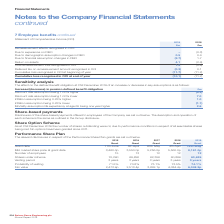According to Spirax Sarco Engineering Plc's financial document, What are the relevant disclosures in the table pertaining to? in respect of the Performance Share Plan grants. The document states: "Performance Share Plan The relevant disclosures in respect of the Performance Share Plan grants are set out below...." Also, What was the number of employees under the 2015 Grant? According to the financial document, 15. The relevant text states: "2015 Grant 2016 Grant 2017 Grant 2018 Grant..." Also, For which years were the relevant disclosures in respect of the Performance Share Plan grants set out? The document contains multiple relevant values: 2015, 2016, 2017, 2018, 2019. From the document: "2018 £m Remeasurement effects recognised in OCI: Due to experience on DBO – (0.3) Due to demographic ass 2015 Grant 2016 Grant 2017 Grant 2018 Grant S..." Additionally, In which year's grant had the largest number of employees? According to the financial document, 2015. The relevant text states: "2015 Grant 2016 Grant 2017 Grant 2018 Grant..." Also, can you calculate: What was the change in the number of shares under scheme under the 2019 Grant from the 2018 Grant? Based on the calculation: 60,626-60,899, the result is -273. This is based on the information: "Shares under scheme 70,290 69,890 62,356 60,899 60,626 Shares under scheme 70,290 69,890 62,356 60,899 60,626..." The key data points involved are: 60,626, 60,899. Also, can you calculate: What was the percentage change in the number of shares under scheme under the 2019 Grant from the 2018 Grant? To answer this question, I need to perform calculations using the financial data. The calculation is: (60,626-60,899)/60,899, which equals -0.45 (percentage). This is based on the information: "Shares under scheme 70,290 69,890 62,356 60,899 60,626 Shares under scheme 70,290 69,890 62,356 60,899 60,626..." The key data points involved are: 60,626, 60,899. 